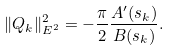<formula> <loc_0><loc_0><loc_500><loc_500>\| Q _ { k } \| ^ { 2 } _ { E ^ { 2 } } = - \frac { \pi } { 2 } \frac { A ^ { \prime } ( s _ { k } ) } { B ( s _ { k } ) } .</formula> 